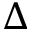Convert formula to latex. <formula><loc_0><loc_0><loc_500><loc_500>\Delta</formula> 